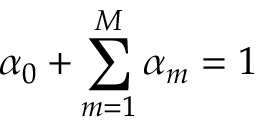<formula> <loc_0><loc_0><loc_500><loc_500>\alpha _ { 0 } + \sum _ { m = 1 } ^ { M } \alpha _ { m } = 1</formula> 